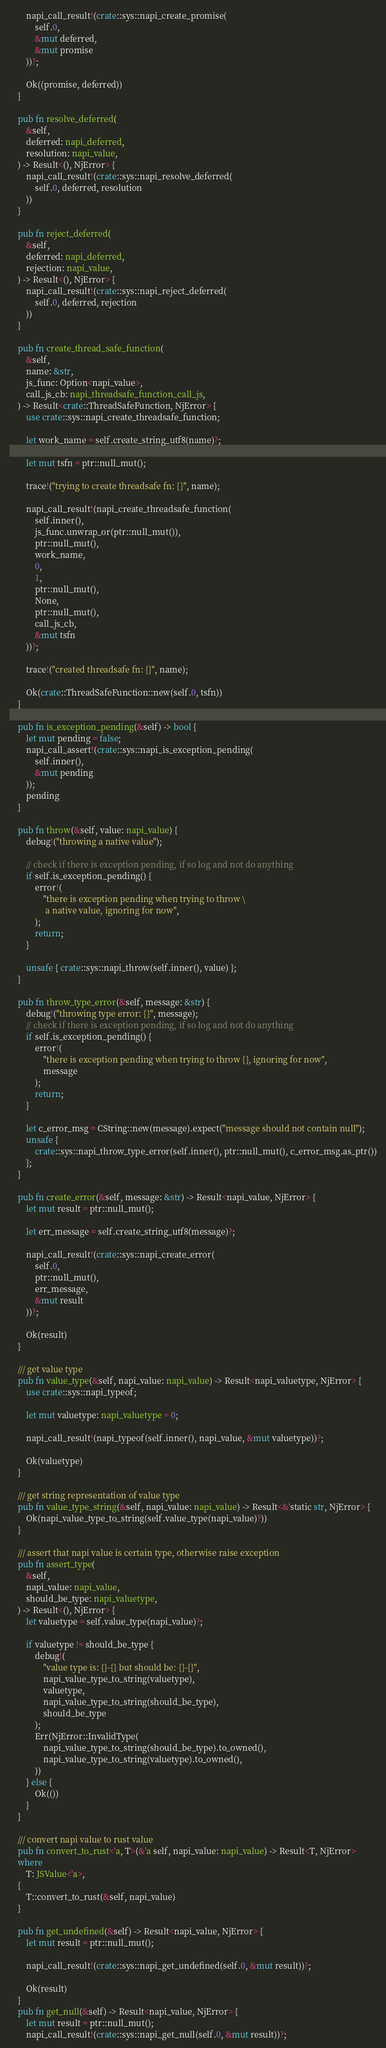<code> <loc_0><loc_0><loc_500><loc_500><_Rust_>        napi_call_result!(crate::sys::napi_create_promise(
            self.0,
            &mut deferred,
            &mut promise
        ))?;

        Ok((promise, deferred))
    }

    pub fn resolve_deferred(
        &self,
        deferred: napi_deferred,
        resolution: napi_value,
    ) -> Result<(), NjError> {
        napi_call_result!(crate::sys::napi_resolve_deferred(
            self.0, deferred, resolution
        ))
    }

    pub fn reject_deferred(
        &self,
        deferred: napi_deferred,
        rejection: napi_value,
    ) -> Result<(), NjError> {
        napi_call_result!(crate::sys::napi_reject_deferred(
            self.0, deferred, rejection
        ))
    }

    pub fn create_thread_safe_function(
        &self,
        name: &str,
        js_func: Option<napi_value>,
        call_js_cb: napi_threadsafe_function_call_js,
    ) -> Result<crate::ThreadSafeFunction, NjError> {
        use crate::sys::napi_create_threadsafe_function;

        let work_name = self.create_string_utf8(name)?;

        let mut tsfn = ptr::null_mut();

        trace!("trying to create threadsafe fn: {}", name);

        napi_call_result!(napi_create_threadsafe_function(
            self.inner(),
            js_func.unwrap_or(ptr::null_mut()),
            ptr::null_mut(),
            work_name,
            0,
            1,
            ptr::null_mut(),
            None,
            ptr::null_mut(),
            call_js_cb,
            &mut tsfn
        ))?;

        trace!("created threadsafe fn: {}", name);

        Ok(crate::ThreadSafeFunction::new(self.0, tsfn))
    }

    pub fn is_exception_pending(&self) -> bool {
        let mut pending = false;
        napi_call_assert!(crate::sys::napi_is_exception_pending(
            self.inner(),
            &mut pending
        ));
        pending
    }

    pub fn throw(&self, value: napi_value) {
        debug!("throwing a native value");

        // check if there is exception pending, if so log and not do anything
        if self.is_exception_pending() {
            error!(
                "there is exception pending when trying to throw \
                 a native value, ignoring for now",
            );
            return;
        }

        unsafe { crate::sys::napi_throw(self.inner(), value) };
    }

    pub fn throw_type_error(&self, message: &str) {
        debug!("throwing type error: {}", message);
        // check if there is exception pending, if so log and not do anything
        if self.is_exception_pending() {
            error!(
                "there is exception pending when trying to throw {}, ignoring for now",
                message
            );
            return;
        }

        let c_error_msg = CString::new(message).expect("message should not contain null");
        unsafe {
            crate::sys::napi_throw_type_error(self.inner(), ptr::null_mut(), c_error_msg.as_ptr())
        };
    }

    pub fn create_error(&self, message: &str) -> Result<napi_value, NjError> {
        let mut result = ptr::null_mut();

        let err_message = self.create_string_utf8(message)?;

        napi_call_result!(crate::sys::napi_create_error(
            self.0,
            ptr::null_mut(),
            err_message,
            &mut result
        ))?;

        Ok(result)
    }

    /// get value type
    pub fn value_type(&self, napi_value: napi_value) -> Result<napi_valuetype, NjError> {
        use crate::sys::napi_typeof;

        let mut valuetype: napi_valuetype = 0;

        napi_call_result!(napi_typeof(self.inner(), napi_value, &mut valuetype))?;

        Ok(valuetype)
    }

    /// get string representation of value type
    pub fn value_type_string(&self, napi_value: napi_value) -> Result<&'static str, NjError> {
        Ok(napi_value_type_to_string(self.value_type(napi_value)?))
    }

    /// assert that napi value is certain type, otherwise raise exception
    pub fn assert_type(
        &self,
        napi_value: napi_value,
        should_be_type: napi_valuetype,
    ) -> Result<(), NjError> {
        let valuetype = self.value_type(napi_value)?;

        if valuetype != should_be_type {
            debug!(
                "value type is: {}-{} but should be: {}-{}",
                napi_value_type_to_string(valuetype),
                valuetype,
                napi_value_type_to_string(should_be_type),
                should_be_type
            );
            Err(NjError::InvalidType(
                napi_value_type_to_string(should_be_type).to_owned(),
                napi_value_type_to_string(valuetype).to_owned(),
            ))
        } else {
            Ok(())
        }
    }

    /// convert napi value to rust value
    pub fn convert_to_rust<'a, T>(&'a self, napi_value: napi_value) -> Result<T, NjError>
    where
        T: JSValue<'a>,
    {
        T::convert_to_rust(&self, napi_value)
    }

    pub fn get_undefined(&self) -> Result<napi_value, NjError> {
        let mut result = ptr::null_mut();

        napi_call_result!(crate::sys::napi_get_undefined(self.0, &mut result))?;

        Ok(result)
    }
    pub fn get_null(&self) -> Result<napi_value, NjError> {
        let mut result = ptr::null_mut();
        napi_call_result!(crate::sys::napi_get_null(self.0, &mut result))?;</code> 